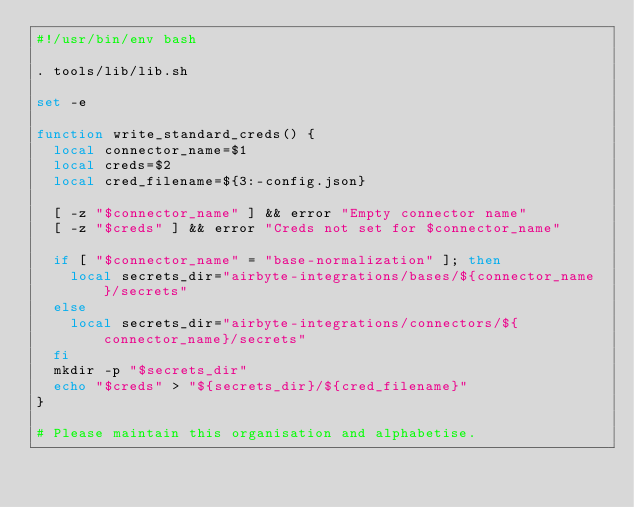Convert code to text. <code><loc_0><loc_0><loc_500><loc_500><_Bash_>#!/usr/bin/env bash

. tools/lib/lib.sh

set -e

function write_standard_creds() {
  local connector_name=$1
  local creds=$2
  local cred_filename=${3:-config.json}

  [ -z "$connector_name" ] && error "Empty connector name"
  [ -z "$creds" ] && error "Creds not set for $connector_name"

  if [ "$connector_name" = "base-normalization" ]; then
    local secrets_dir="airbyte-integrations/bases/${connector_name}/secrets"
  else
    local secrets_dir="airbyte-integrations/connectors/${connector_name}/secrets"
  fi
  mkdir -p "$secrets_dir"
  echo "$creds" > "${secrets_dir}/${cred_filename}"
}

# Please maintain this organisation and alphabetise.</code> 